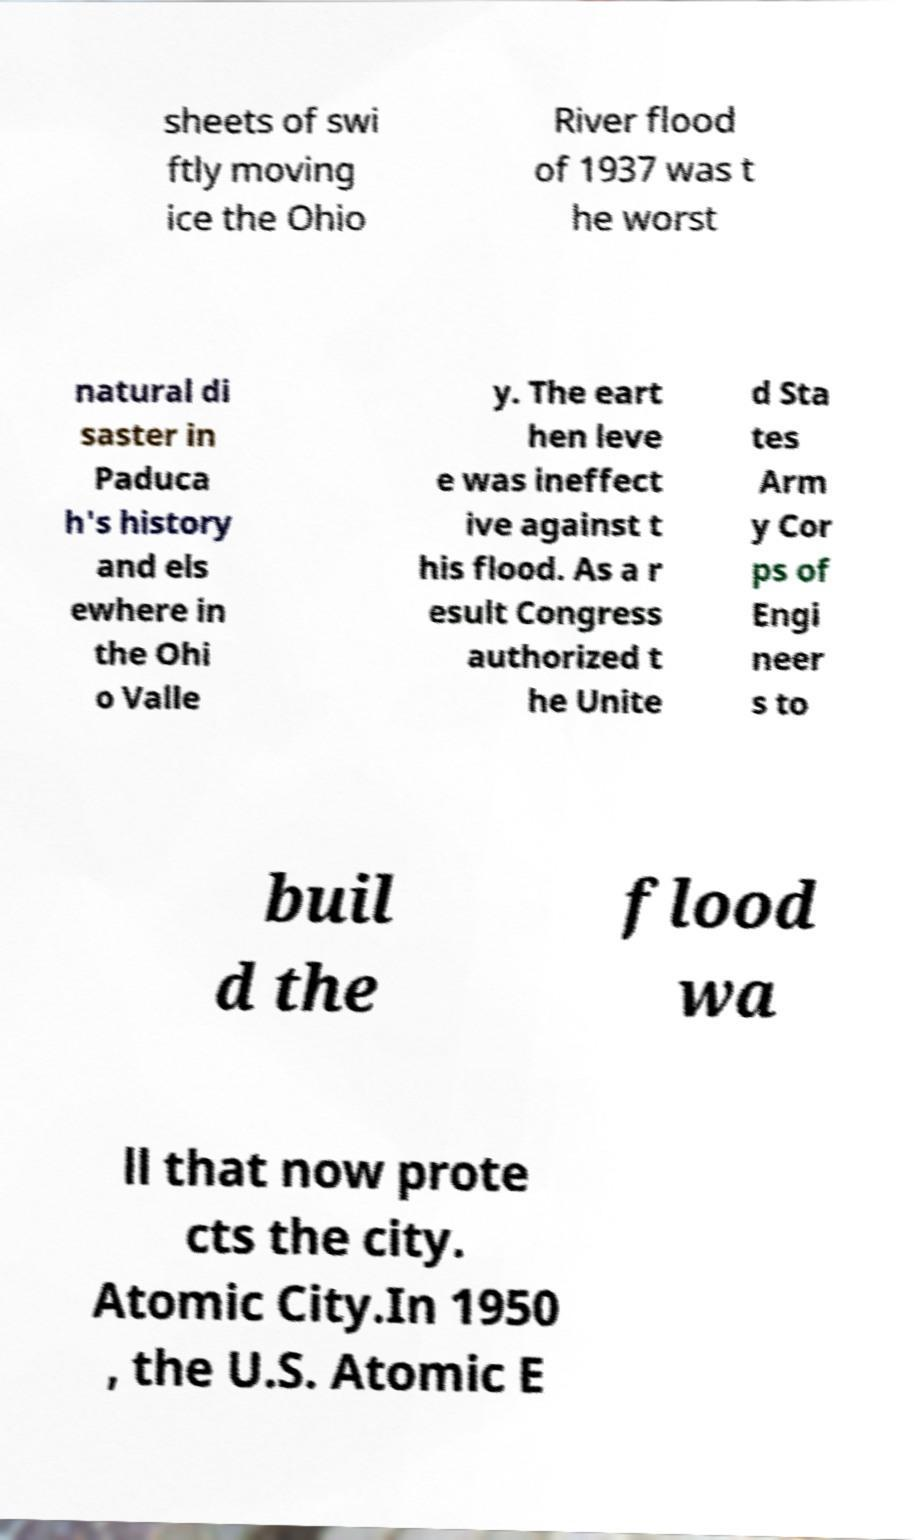For documentation purposes, I need the text within this image transcribed. Could you provide that? sheets of swi ftly moving ice the Ohio River flood of 1937 was t he worst natural di saster in Paduca h's history and els ewhere in the Ohi o Valle y. The eart hen leve e was ineffect ive against t his flood. As a r esult Congress authorized t he Unite d Sta tes Arm y Cor ps of Engi neer s to buil d the flood wa ll that now prote cts the city. Atomic City.In 1950 , the U.S. Atomic E 